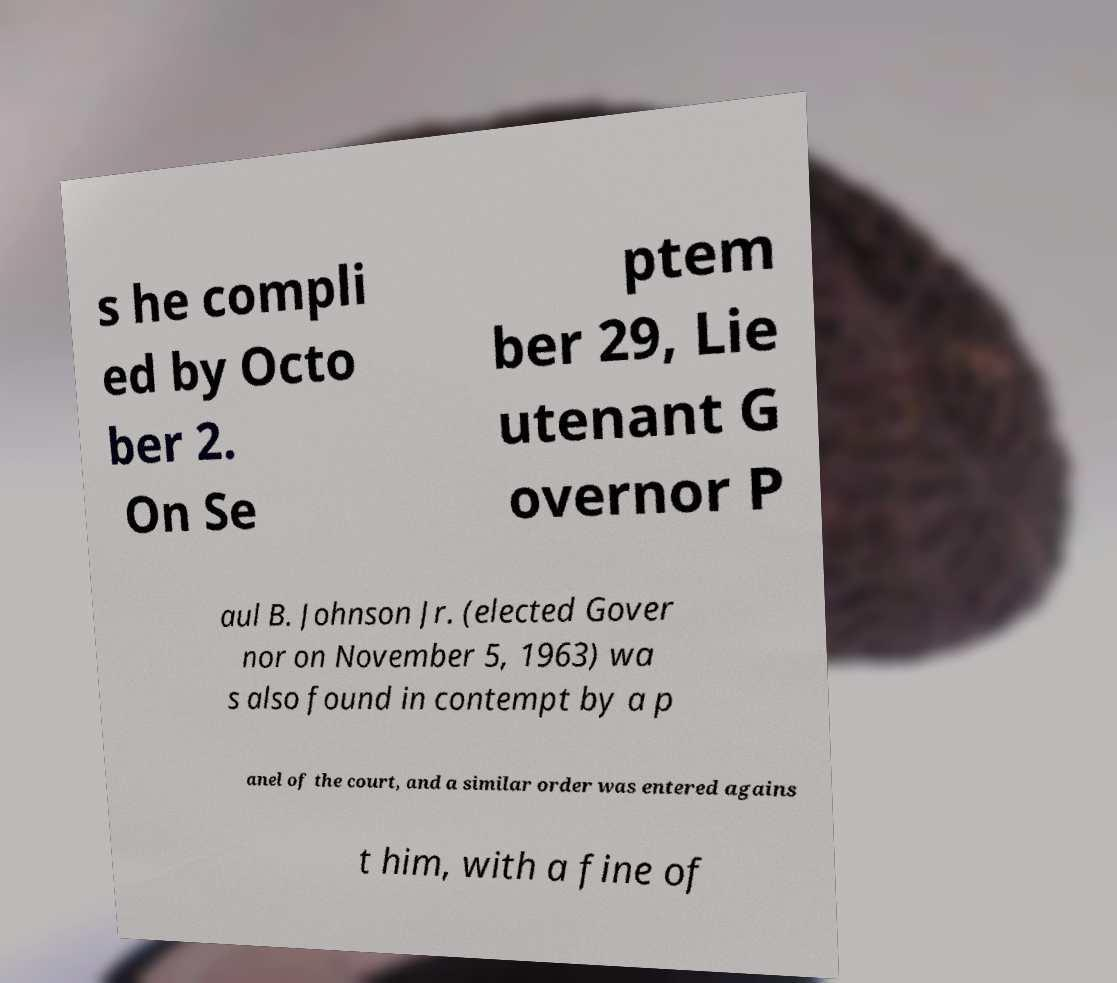Please read and relay the text visible in this image. What does it say? s he compli ed by Octo ber 2. On Se ptem ber 29, Lie utenant G overnor P aul B. Johnson Jr. (elected Gover nor on November 5, 1963) wa s also found in contempt by a p anel of the court, and a similar order was entered agains t him, with a fine of 